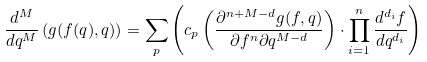<formula> <loc_0><loc_0><loc_500><loc_500>\frac { d ^ { M } } { d q ^ { M } } \left ( g ( f ( q ) , q ) \right ) = \sum _ { p } \left ( c _ { p } \left ( \frac { \partial ^ { n + M - d } g ( f , q ) } { \partial f ^ { n } \partial q ^ { M - d } } \right ) \cdot \prod _ { i = 1 } ^ { n } \frac { d ^ { d _ { i } } f } { d q ^ { d _ { i } } } \right )</formula> 